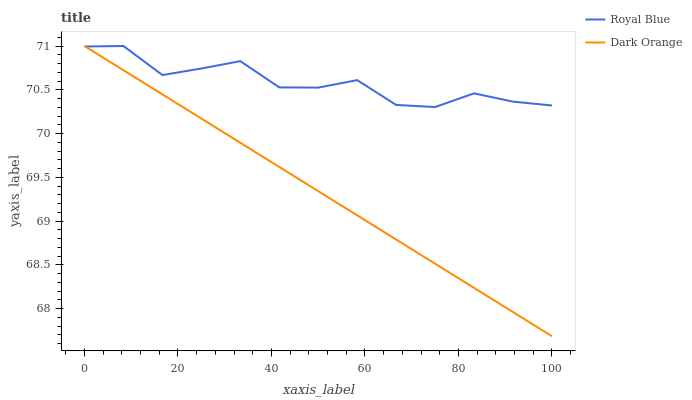Does Dark Orange have the minimum area under the curve?
Answer yes or no. Yes. Does Royal Blue have the maximum area under the curve?
Answer yes or no. Yes. Does Dark Orange have the maximum area under the curve?
Answer yes or no. No. Is Dark Orange the smoothest?
Answer yes or no. Yes. Is Royal Blue the roughest?
Answer yes or no. Yes. Is Dark Orange the roughest?
Answer yes or no. No. Does Dark Orange have the lowest value?
Answer yes or no. Yes. Does Dark Orange have the highest value?
Answer yes or no. Yes. Does Dark Orange intersect Royal Blue?
Answer yes or no. Yes. Is Dark Orange less than Royal Blue?
Answer yes or no. No. Is Dark Orange greater than Royal Blue?
Answer yes or no. No. 